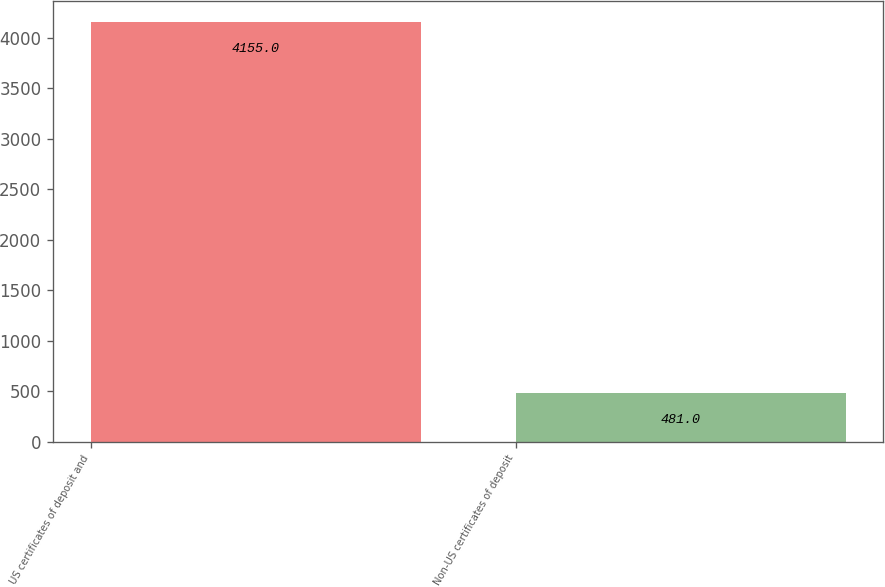Convert chart. <chart><loc_0><loc_0><loc_500><loc_500><bar_chart><fcel>US certificates of deposit and<fcel>Non-US certificates of deposit<nl><fcel>4155<fcel>481<nl></chart> 